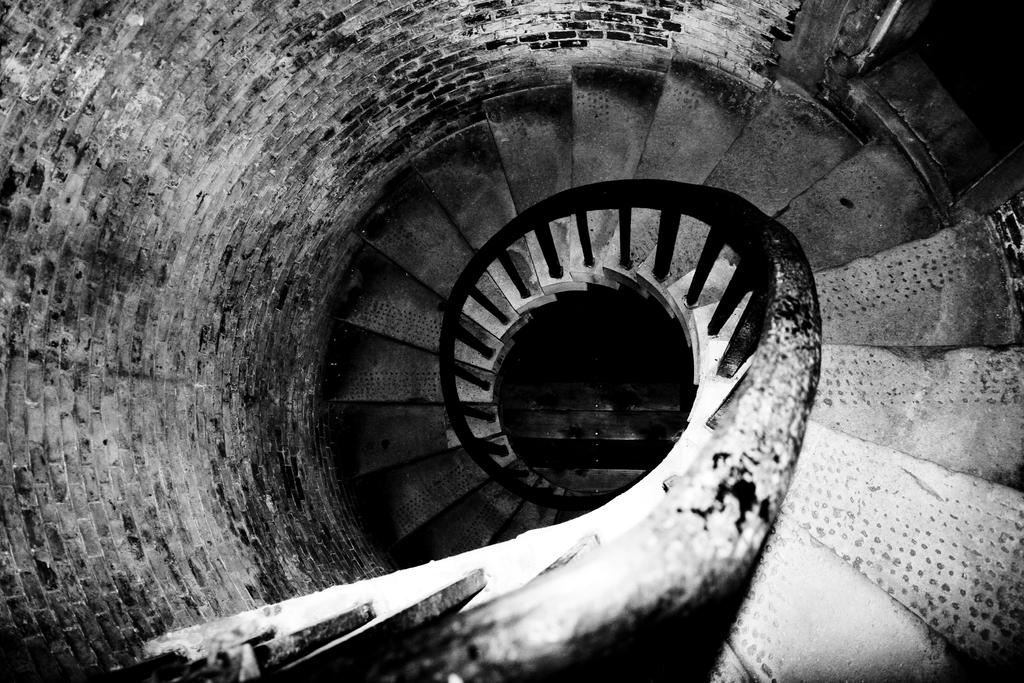What type of architectural feature is present in the image? There are stairs in the image. Is there any additional support or safety feature present on the stairs? Yes, there is a railing in the image. What other structural element can be seen in the image? There is a wall in the image. How is the image presented in terms of color? The image is in black and white. How many snakes are slithering up the stairs in the image? There are no snakes present in the image; it only features stairs, a railing, and a wall. What type of business is being conducted on the stairs in the image? There is no business activity depicted in the image; it only shows stairs, a railing, and a wall. 